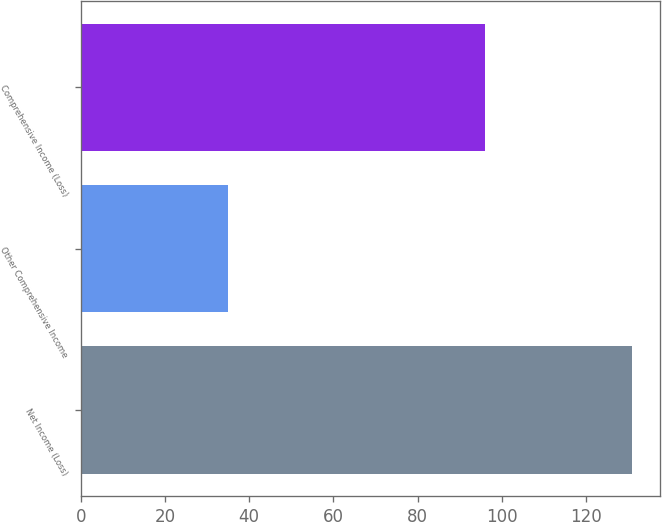Convert chart. <chart><loc_0><loc_0><loc_500><loc_500><bar_chart><fcel>Net Income (Loss)<fcel>Other Comprehensive Income<fcel>Comprehensive Income (Loss)<nl><fcel>131<fcel>35<fcel>96<nl></chart> 